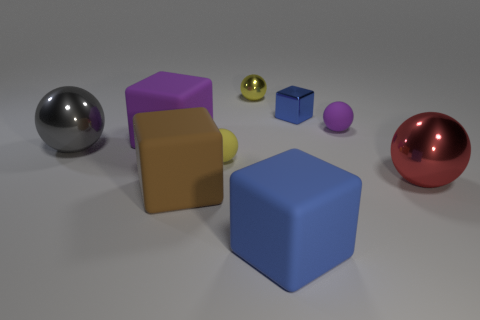Subtract all red balls. How many balls are left? 4 Subtract all green balls. Subtract all brown cylinders. How many balls are left? 5 Add 1 small matte spheres. How many objects exist? 10 Subtract all blocks. How many objects are left? 5 Subtract all matte spheres. Subtract all gray metal objects. How many objects are left? 6 Add 8 yellow balls. How many yellow balls are left? 10 Add 6 large red metal spheres. How many large red metal spheres exist? 7 Subtract 1 gray spheres. How many objects are left? 8 